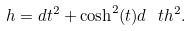<formula> <loc_0><loc_0><loc_500><loc_500>h = d t ^ { 2 } + \cosh ^ { 2 } ( t ) d \ t h ^ { 2 } .</formula> 